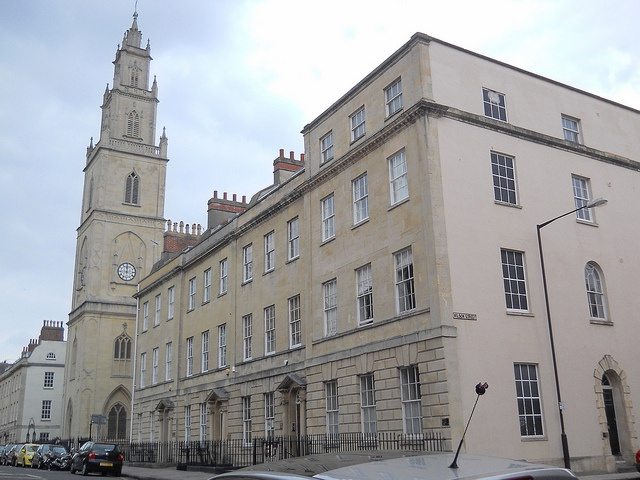Describe the objects in this image and their specific colors. I can see car in darkgray, black, and gray tones, car in darkgray, black, and gray tones, car in darkgray, gray, olive, and black tones, clock in darkgray, gray, and lightgray tones, and car in darkgray, black, and gray tones in this image. 